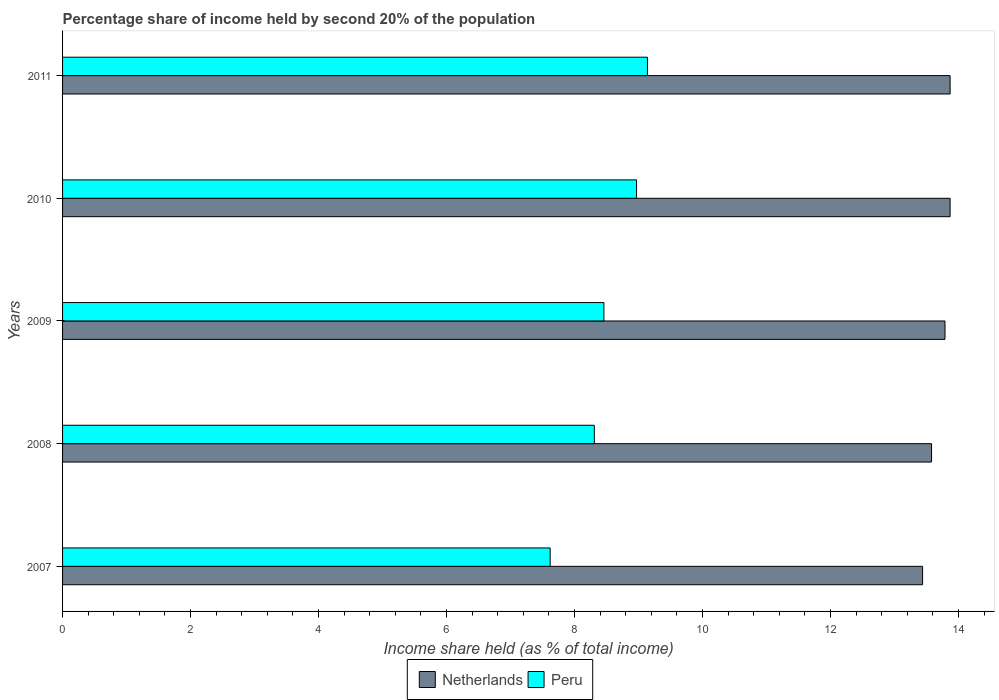Are the number of bars per tick equal to the number of legend labels?
Ensure brevity in your answer.  Yes. Are the number of bars on each tick of the Y-axis equal?
Your response must be concise. Yes. How many bars are there on the 1st tick from the top?
Your response must be concise. 2. How many bars are there on the 2nd tick from the bottom?
Provide a succinct answer. 2. What is the label of the 4th group of bars from the top?
Keep it short and to the point. 2008. What is the share of income held by second 20% of the population in Peru in 2011?
Provide a short and direct response. 9.14. Across all years, what is the maximum share of income held by second 20% of the population in Peru?
Provide a short and direct response. 9.14. Across all years, what is the minimum share of income held by second 20% of the population in Peru?
Your response must be concise. 7.62. What is the total share of income held by second 20% of the population in Netherlands in the graph?
Your answer should be very brief. 68.55. What is the difference between the share of income held by second 20% of the population in Netherlands in 2010 and the share of income held by second 20% of the population in Peru in 2009?
Keep it short and to the point. 5.41. In the year 2008, what is the difference between the share of income held by second 20% of the population in Peru and share of income held by second 20% of the population in Netherlands?
Provide a short and direct response. -5.27. In how many years, is the share of income held by second 20% of the population in Netherlands greater than 10 %?
Your response must be concise. 5. What is the ratio of the share of income held by second 20% of the population in Peru in 2010 to that in 2011?
Keep it short and to the point. 0.98. Is the share of income held by second 20% of the population in Netherlands in 2008 less than that in 2009?
Offer a very short reply. Yes. What is the difference between the highest and the second highest share of income held by second 20% of the population in Peru?
Ensure brevity in your answer.  0.17. What is the difference between the highest and the lowest share of income held by second 20% of the population in Peru?
Offer a terse response. 1.52. What does the 2nd bar from the top in 2011 represents?
Your response must be concise. Netherlands. What does the 1st bar from the bottom in 2010 represents?
Your response must be concise. Netherlands. Are all the bars in the graph horizontal?
Your answer should be compact. Yes. What is the difference between two consecutive major ticks on the X-axis?
Make the answer very short. 2. Does the graph contain any zero values?
Keep it short and to the point. No. How many legend labels are there?
Provide a succinct answer. 2. How are the legend labels stacked?
Your answer should be very brief. Horizontal. What is the title of the graph?
Offer a very short reply. Percentage share of income held by second 20% of the population. What is the label or title of the X-axis?
Your answer should be very brief. Income share held (as % of total income). What is the label or title of the Y-axis?
Offer a terse response. Years. What is the Income share held (as % of total income) of Netherlands in 2007?
Ensure brevity in your answer.  13.44. What is the Income share held (as % of total income) in Peru in 2007?
Offer a terse response. 7.62. What is the Income share held (as % of total income) of Netherlands in 2008?
Your response must be concise. 13.58. What is the Income share held (as % of total income) in Peru in 2008?
Offer a very short reply. 8.31. What is the Income share held (as % of total income) of Netherlands in 2009?
Offer a terse response. 13.79. What is the Income share held (as % of total income) in Peru in 2009?
Provide a succinct answer. 8.46. What is the Income share held (as % of total income) of Netherlands in 2010?
Offer a very short reply. 13.87. What is the Income share held (as % of total income) in Peru in 2010?
Make the answer very short. 8.97. What is the Income share held (as % of total income) in Netherlands in 2011?
Provide a succinct answer. 13.87. What is the Income share held (as % of total income) in Peru in 2011?
Provide a short and direct response. 9.14. Across all years, what is the maximum Income share held (as % of total income) in Netherlands?
Provide a short and direct response. 13.87. Across all years, what is the maximum Income share held (as % of total income) in Peru?
Keep it short and to the point. 9.14. Across all years, what is the minimum Income share held (as % of total income) of Netherlands?
Your response must be concise. 13.44. Across all years, what is the minimum Income share held (as % of total income) in Peru?
Your answer should be very brief. 7.62. What is the total Income share held (as % of total income) in Netherlands in the graph?
Give a very brief answer. 68.55. What is the total Income share held (as % of total income) in Peru in the graph?
Give a very brief answer. 42.5. What is the difference between the Income share held (as % of total income) in Netherlands in 2007 and that in 2008?
Your answer should be compact. -0.14. What is the difference between the Income share held (as % of total income) in Peru in 2007 and that in 2008?
Offer a terse response. -0.69. What is the difference between the Income share held (as % of total income) of Netherlands in 2007 and that in 2009?
Keep it short and to the point. -0.35. What is the difference between the Income share held (as % of total income) in Peru in 2007 and that in 2009?
Ensure brevity in your answer.  -0.84. What is the difference between the Income share held (as % of total income) in Netherlands in 2007 and that in 2010?
Your answer should be very brief. -0.43. What is the difference between the Income share held (as % of total income) in Peru in 2007 and that in 2010?
Provide a short and direct response. -1.35. What is the difference between the Income share held (as % of total income) of Netherlands in 2007 and that in 2011?
Offer a very short reply. -0.43. What is the difference between the Income share held (as % of total income) in Peru in 2007 and that in 2011?
Ensure brevity in your answer.  -1.52. What is the difference between the Income share held (as % of total income) of Netherlands in 2008 and that in 2009?
Give a very brief answer. -0.21. What is the difference between the Income share held (as % of total income) of Netherlands in 2008 and that in 2010?
Make the answer very short. -0.29. What is the difference between the Income share held (as % of total income) in Peru in 2008 and that in 2010?
Offer a terse response. -0.66. What is the difference between the Income share held (as % of total income) of Netherlands in 2008 and that in 2011?
Make the answer very short. -0.29. What is the difference between the Income share held (as % of total income) in Peru in 2008 and that in 2011?
Offer a very short reply. -0.83. What is the difference between the Income share held (as % of total income) of Netherlands in 2009 and that in 2010?
Give a very brief answer. -0.08. What is the difference between the Income share held (as % of total income) in Peru in 2009 and that in 2010?
Provide a succinct answer. -0.51. What is the difference between the Income share held (as % of total income) in Netherlands in 2009 and that in 2011?
Make the answer very short. -0.08. What is the difference between the Income share held (as % of total income) in Peru in 2009 and that in 2011?
Your answer should be very brief. -0.68. What is the difference between the Income share held (as % of total income) of Netherlands in 2010 and that in 2011?
Give a very brief answer. 0. What is the difference between the Income share held (as % of total income) in Peru in 2010 and that in 2011?
Make the answer very short. -0.17. What is the difference between the Income share held (as % of total income) of Netherlands in 2007 and the Income share held (as % of total income) of Peru in 2008?
Offer a terse response. 5.13. What is the difference between the Income share held (as % of total income) of Netherlands in 2007 and the Income share held (as % of total income) of Peru in 2009?
Give a very brief answer. 4.98. What is the difference between the Income share held (as % of total income) of Netherlands in 2007 and the Income share held (as % of total income) of Peru in 2010?
Ensure brevity in your answer.  4.47. What is the difference between the Income share held (as % of total income) of Netherlands in 2008 and the Income share held (as % of total income) of Peru in 2009?
Offer a very short reply. 5.12. What is the difference between the Income share held (as % of total income) in Netherlands in 2008 and the Income share held (as % of total income) in Peru in 2010?
Your answer should be very brief. 4.61. What is the difference between the Income share held (as % of total income) of Netherlands in 2008 and the Income share held (as % of total income) of Peru in 2011?
Your response must be concise. 4.44. What is the difference between the Income share held (as % of total income) in Netherlands in 2009 and the Income share held (as % of total income) in Peru in 2010?
Provide a short and direct response. 4.82. What is the difference between the Income share held (as % of total income) of Netherlands in 2009 and the Income share held (as % of total income) of Peru in 2011?
Offer a terse response. 4.65. What is the difference between the Income share held (as % of total income) of Netherlands in 2010 and the Income share held (as % of total income) of Peru in 2011?
Keep it short and to the point. 4.73. What is the average Income share held (as % of total income) of Netherlands per year?
Make the answer very short. 13.71. What is the average Income share held (as % of total income) in Peru per year?
Provide a succinct answer. 8.5. In the year 2007, what is the difference between the Income share held (as % of total income) of Netherlands and Income share held (as % of total income) of Peru?
Give a very brief answer. 5.82. In the year 2008, what is the difference between the Income share held (as % of total income) in Netherlands and Income share held (as % of total income) in Peru?
Ensure brevity in your answer.  5.27. In the year 2009, what is the difference between the Income share held (as % of total income) of Netherlands and Income share held (as % of total income) of Peru?
Your answer should be compact. 5.33. In the year 2011, what is the difference between the Income share held (as % of total income) of Netherlands and Income share held (as % of total income) of Peru?
Your answer should be very brief. 4.73. What is the ratio of the Income share held (as % of total income) in Peru in 2007 to that in 2008?
Provide a short and direct response. 0.92. What is the ratio of the Income share held (as % of total income) in Netherlands in 2007 to that in 2009?
Your response must be concise. 0.97. What is the ratio of the Income share held (as % of total income) of Peru in 2007 to that in 2009?
Give a very brief answer. 0.9. What is the ratio of the Income share held (as % of total income) of Netherlands in 2007 to that in 2010?
Offer a terse response. 0.97. What is the ratio of the Income share held (as % of total income) in Peru in 2007 to that in 2010?
Ensure brevity in your answer.  0.85. What is the ratio of the Income share held (as % of total income) of Peru in 2007 to that in 2011?
Ensure brevity in your answer.  0.83. What is the ratio of the Income share held (as % of total income) of Peru in 2008 to that in 2009?
Provide a succinct answer. 0.98. What is the ratio of the Income share held (as % of total income) in Netherlands in 2008 to that in 2010?
Provide a short and direct response. 0.98. What is the ratio of the Income share held (as % of total income) in Peru in 2008 to that in 2010?
Your response must be concise. 0.93. What is the ratio of the Income share held (as % of total income) of Netherlands in 2008 to that in 2011?
Ensure brevity in your answer.  0.98. What is the ratio of the Income share held (as % of total income) of Peru in 2008 to that in 2011?
Make the answer very short. 0.91. What is the ratio of the Income share held (as % of total income) of Netherlands in 2009 to that in 2010?
Offer a very short reply. 0.99. What is the ratio of the Income share held (as % of total income) of Peru in 2009 to that in 2010?
Offer a terse response. 0.94. What is the ratio of the Income share held (as % of total income) in Netherlands in 2009 to that in 2011?
Give a very brief answer. 0.99. What is the ratio of the Income share held (as % of total income) in Peru in 2009 to that in 2011?
Make the answer very short. 0.93. What is the ratio of the Income share held (as % of total income) in Peru in 2010 to that in 2011?
Ensure brevity in your answer.  0.98. What is the difference between the highest and the second highest Income share held (as % of total income) in Netherlands?
Keep it short and to the point. 0. What is the difference between the highest and the second highest Income share held (as % of total income) of Peru?
Ensure brevity in your answer.  0.17. What is the difference between the highest and the lowest Income share held (as % of total income) in Netherlands?
Provide a short and direct response. 0.43. What is the difference between the highest and the lowest Income share held (as % of total income) in Peru?
Ensure brevity in your answer.  1.52. 